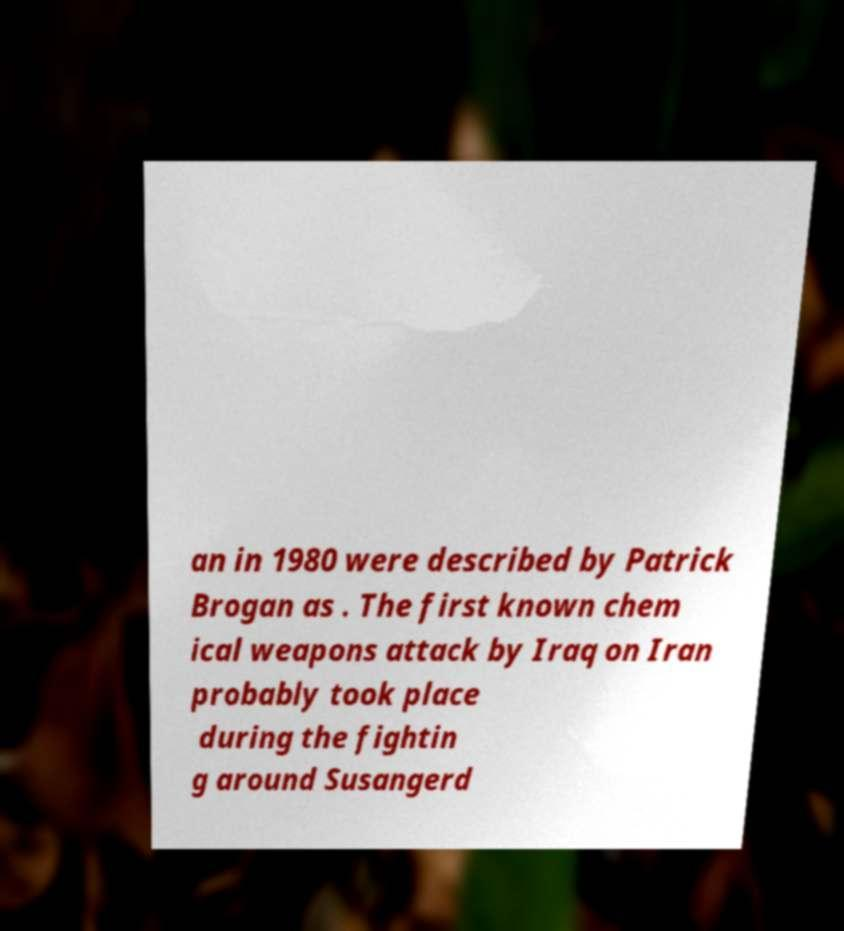Could you extract and type out the text from this image? an in 1980 were described by Patrick Brogan as . The first known chem ical weapons attack by Iraq on Iran probably took place during the fightin g around Susangerd 